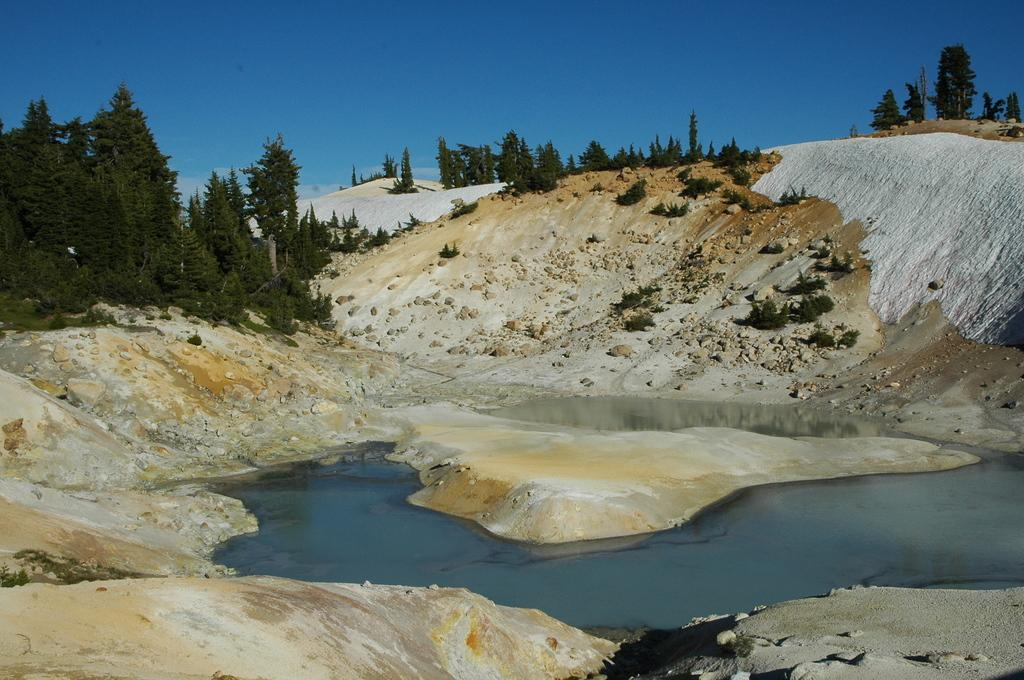What can be seen in the background of the image? The sky is visible in the background of the image. What type of natural features are present in the image? There are trees, hills, and plants in the image. What is the water feature in the image? There is water visible in the image. What type of material can be seen on the ground in the image? There are stones in the image. How many books are stacked on the observation deck in the image? There is no observation deck or books present in the image. What type of plastic objects can be seen in the image? There are no plastic objects present in the image. 